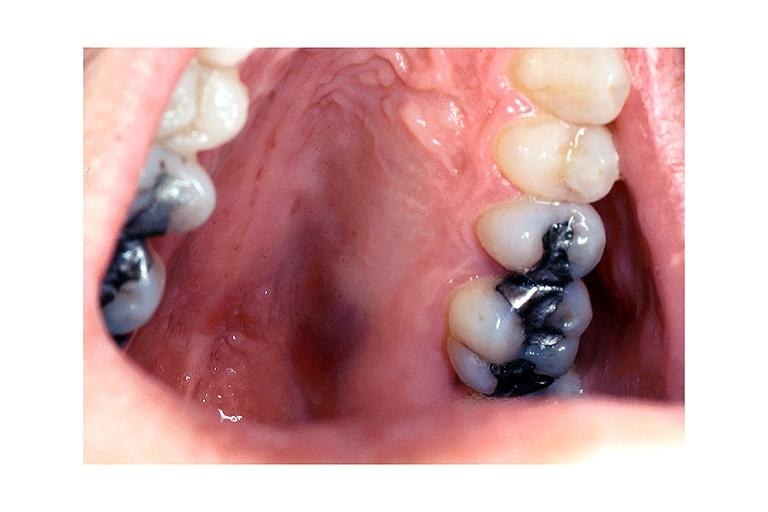s iron present?
Answer the question using a single word or phrase. No 